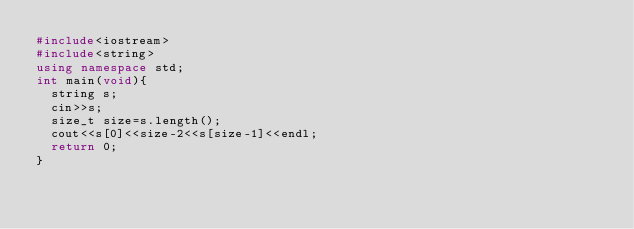Convert code to text. <code><loc_0><loc_0><loc_500><loc_500><_C++_>#include<iostream>
#include<string>
using namespace std;
int main(void){
  string s;
  cin>>s;
  size_t size=s.length();
  cout<<s[0]<<size-2<<s[size-1]<<endl;
  return 0;
}</code> 